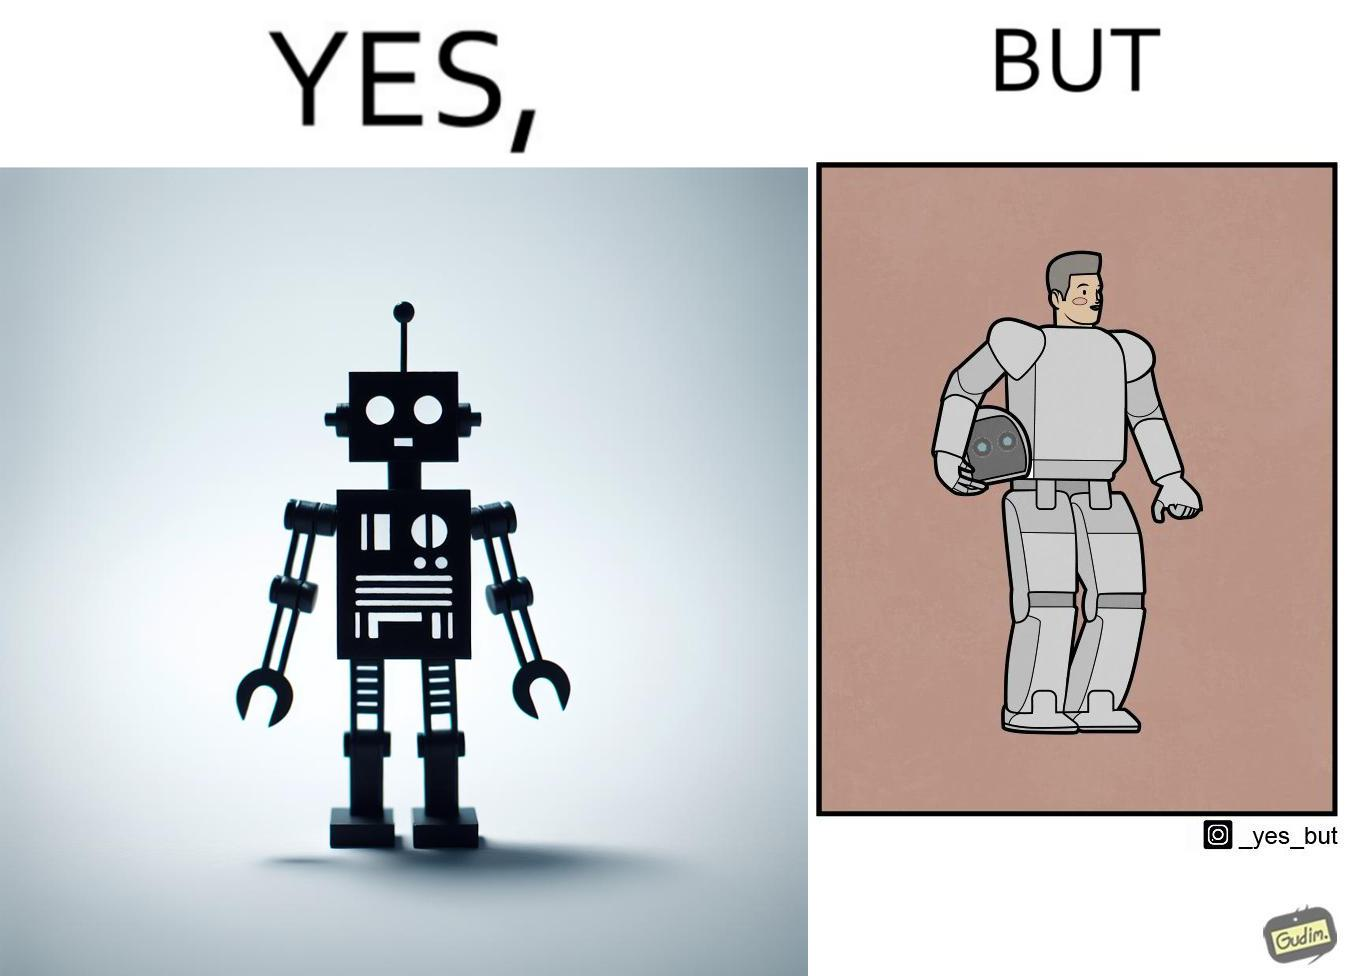What makes this image funny or satirical? The images are ironic since we work to improve technology and build innovations like robots, but in the process we ourselves become less human and robotic in the way we function. 